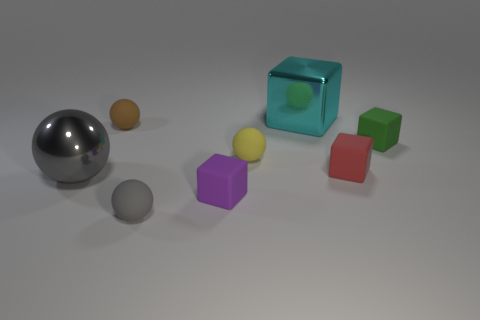Do the gray ball that is behind the gray matte object and the small purple block have the same material?
Your response must be concise. No. Is there anything else that is made of the same material as the purple object?
Provide a short and direct response. Yes. There is a shiny object that is in front of the shiny thing that is to the right of the small gray rubber object; what is its size?
Offer a very short reply. Large. There is a metal thing that is left of the big thing behind the large metal thing to the left of the cyan shiny object; how big is it?
Ensure brevity in your answer.  Large. There is a big thing that is in front of the yellow rubber sphere; is it the same shape as the shiny object behind the yellow matte object?
Provide a short and direct response. No. How many other things are the same color as the large block?
Ensure brevity in your answer.  0. Do the metal thing that is right of the yellow rubber thing and the green rubber thing have the same size?
Provide a short and direct response. No. Are the cube that is on the left side of the yellow object and the big object that is to the left of the large shiny block made of the same material?
Offer a terse response. No. Is there a green cube of the same size as the cyan shiny cube?
Your answer should be very brief. No. There is a shiny object that is right of the cube that is to the left of the large thing that is behind the small red block; what shape is it?
Ensure brevity in your answer.  Cube. 